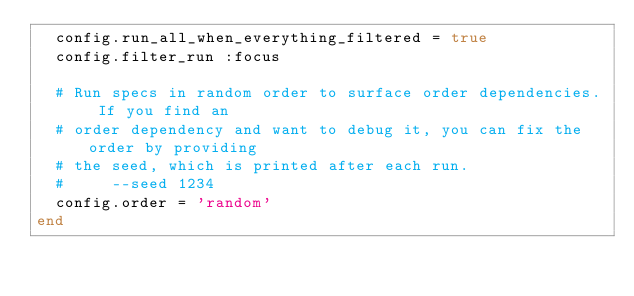<code> <loc_0><loc_0><loc_500><loc_500><_Ruby_>  config.run_all_when_everything_filtered = true
  config.filter_run :focus

  # Run specs in random order to surface order dependencies. If you find an
  # order dependency and want to debug it, you can fix the order by providing
  # the seed, which is printed after each run.
  #     --seed 1234
  config.order = 'random'
end
</code> 